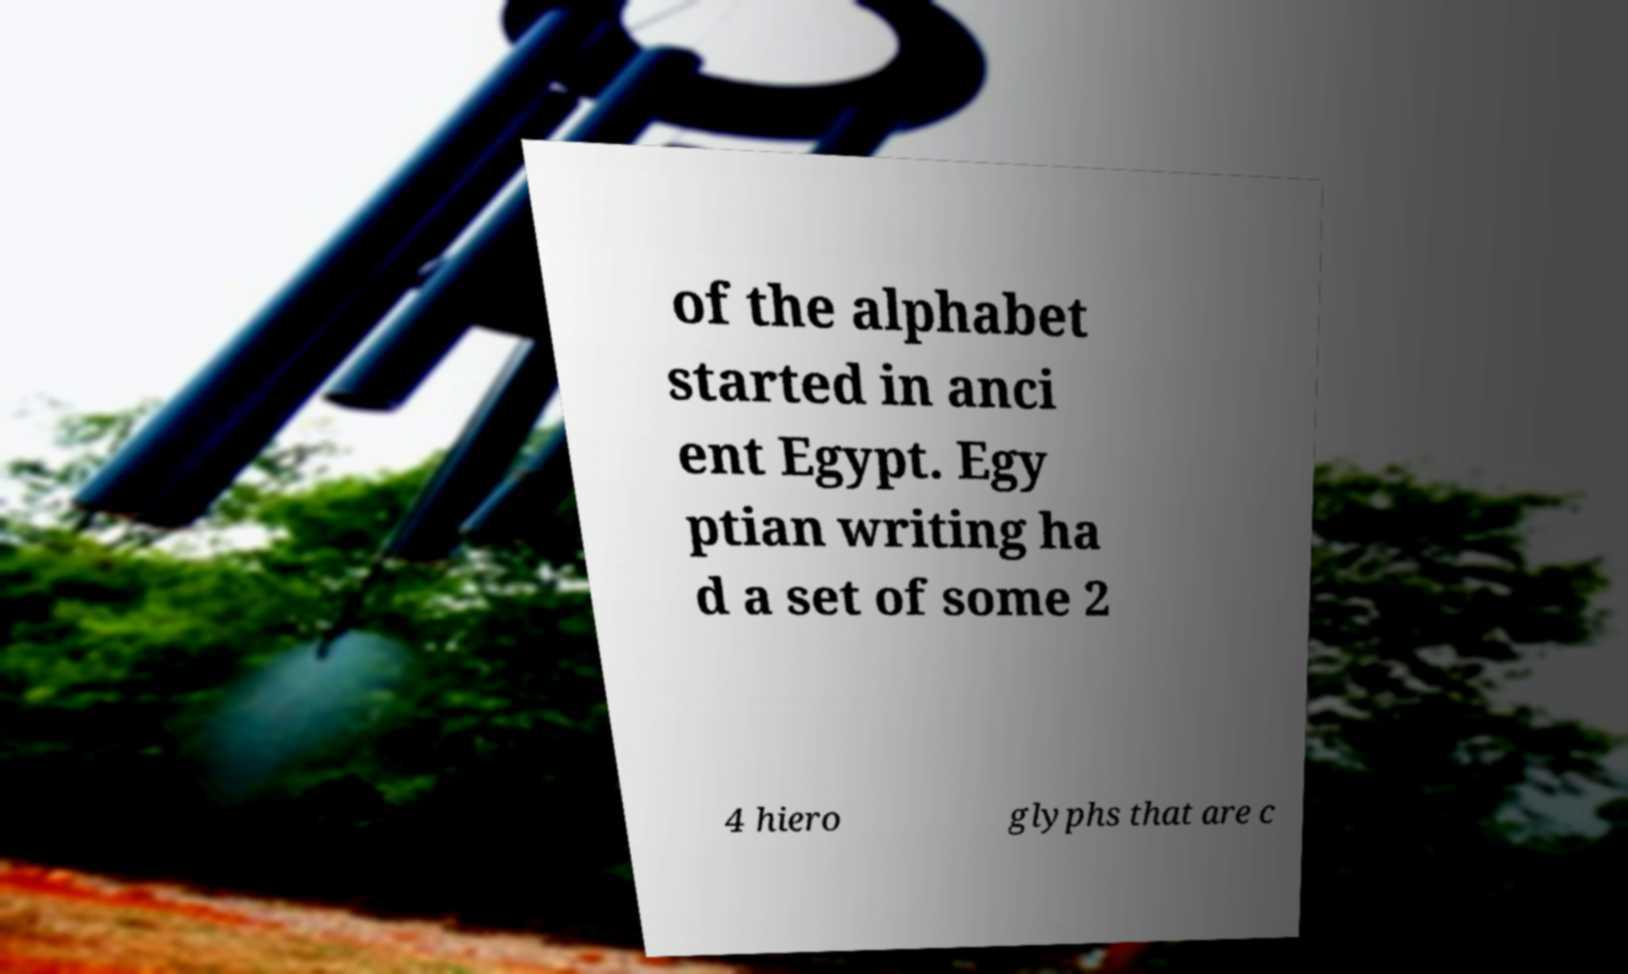I need the written content from this picture converted into text. Can you do that? of the alphabet started in anci ent Egypt. Egy ptian writing ha d a set of some 2 4 hiero glyphs that are c 